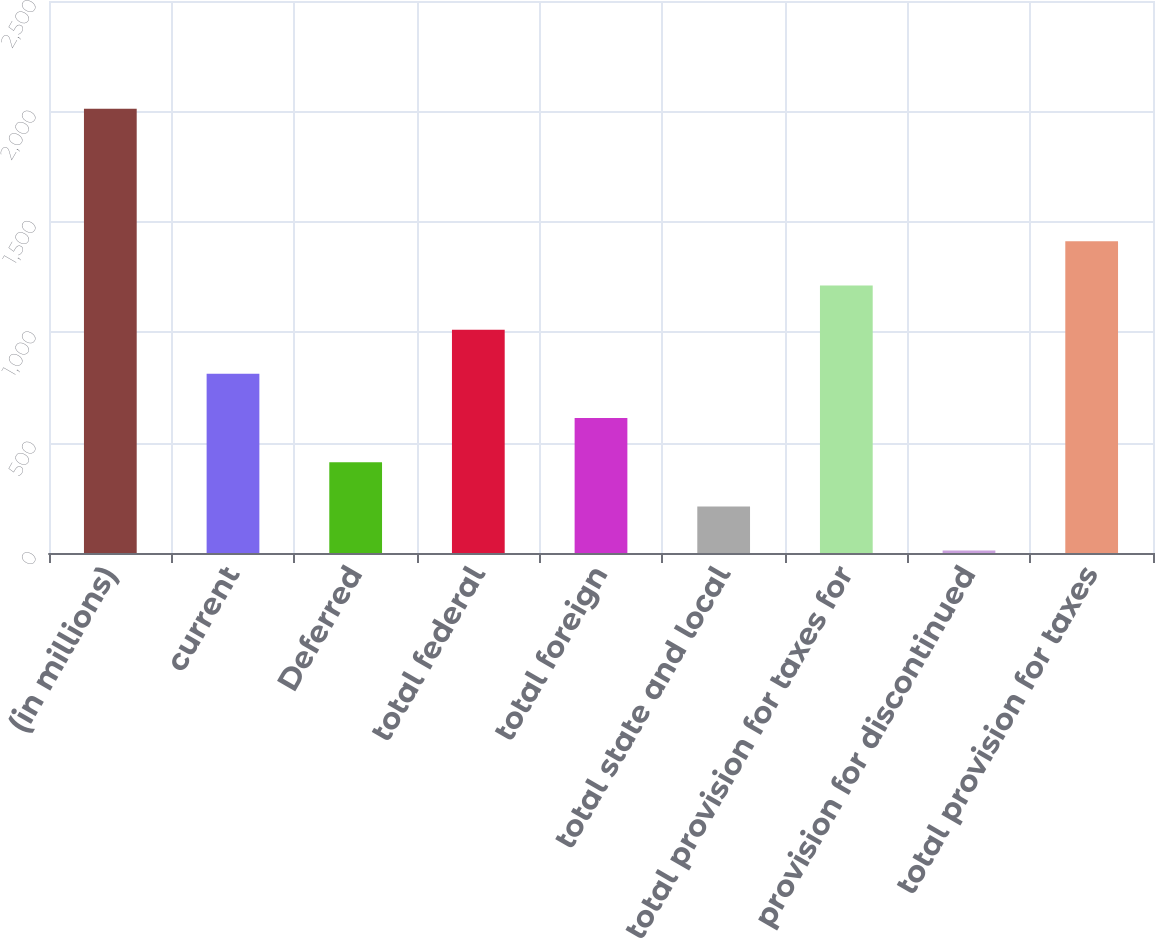Convert chart. <chart><loc_0><loc_0><loc_500><loc_500><bar_chart><fcel>(in millions)<fcel>current<fcel>Deferred<fcel>total federal<fcel>total foreign<fcel>total state and local<fcel>total provision for taxes for<fcel>provision for discontinued<fcel>total provision for taxes<nl><fcel>2012<fcel>811.4<fcel>411.2<fcel>1011.5<fcel>611.3<fcel>211.1<fcel>1211.6<fcel>11<fcel>1411.7<nl></chart> 